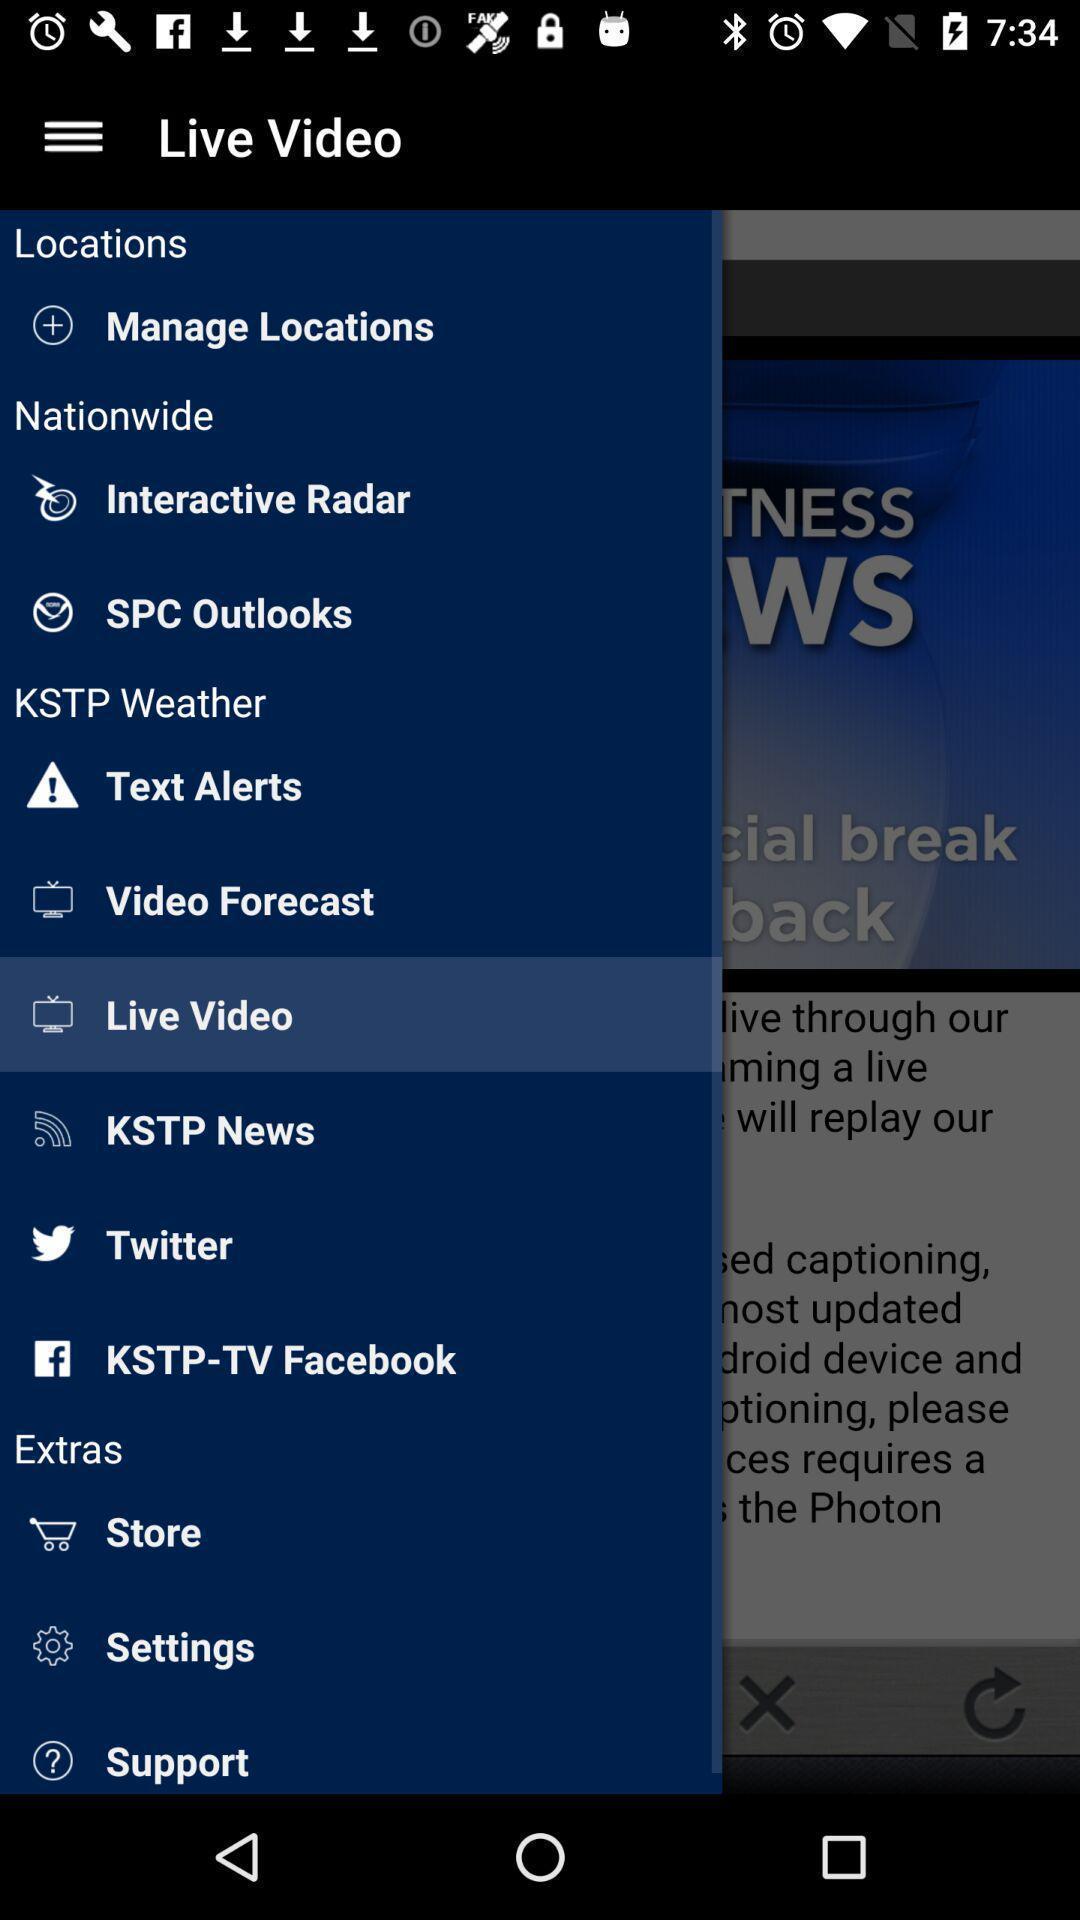Tell me about the visual elements in this screen capture. Screen displaying the options in more menu. 